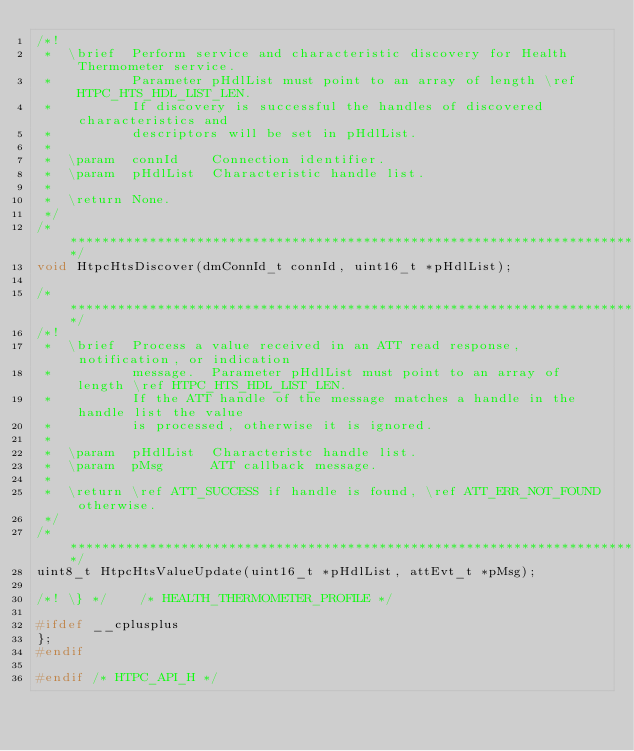<code> <loc_0><loc_0><loc_500><loc_500><_C_>/*!
 *  \brief  Perform service and characteristic discovery for Health Thermometer service.
 *          Parameter pHdlList must point to an array of length \ref HTPC_HTS_HDL_LIST_LEN.
 *          If discovery is successful the handles of discovered characteristics and
 *          descriptors will be set in pHdlList.
 *
 *  \param  connId    Connection identifier.
 *  \param  pHdlList  Characteristic handle list.
 *
 *  \return None.
 */
/*************************************************************************************************/
void HtpcHtsDiscover(dmConnId_t connId, uint16_t *pHdlList);

/*************************************************************************************************/
/*!
 *  \brief  Process a value received in an ATT read response, notification, or indication
 *          message.  Parameter pHdlList must point to an array of length \ref HTPC_HTS_HDL_LIST_LEN.
 *          If the ATT handle of the message matches a handle in the handle list the value
 *          is processed, otherwise it is ignored.
 *
 *  \param  pHdlList  Characteristc handle list.
 *  \param  pMsg      ATT callback message.
 *
 *  \return \ref ATT_SUCCESS if handle is found, \ref ATT_ERR_NOT_FOUND otherwise.
 */
/*************************************************************************************************/
uint8_t HtpcHtsValueUpdate(uint16_t *pHdlList, attEvt_t *pMsg);

/*! \} */    /* HEALTH_THERMOMETER_PROFILE */

#ifdef __cplusplus
};
#endif

#endif /* HTPC_API_H */
</code> 